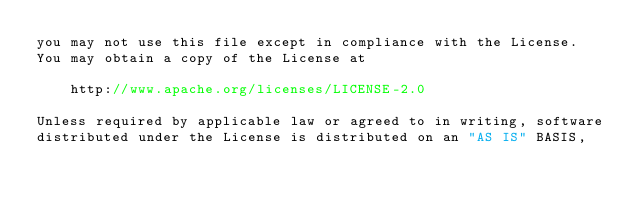Convert code to text. <code><loc_0><loc_0><loc_500><loc_500><_Go_>you may not use this file except in compliance with the License.
You may obtain a copy of the License at

    http://www.apache.org/licenses/LICENSE-2.0

Unless required by applicable law or agreed to in writing, software
distributed under the License is distributed on an "AS IS" BASIS,</code> 